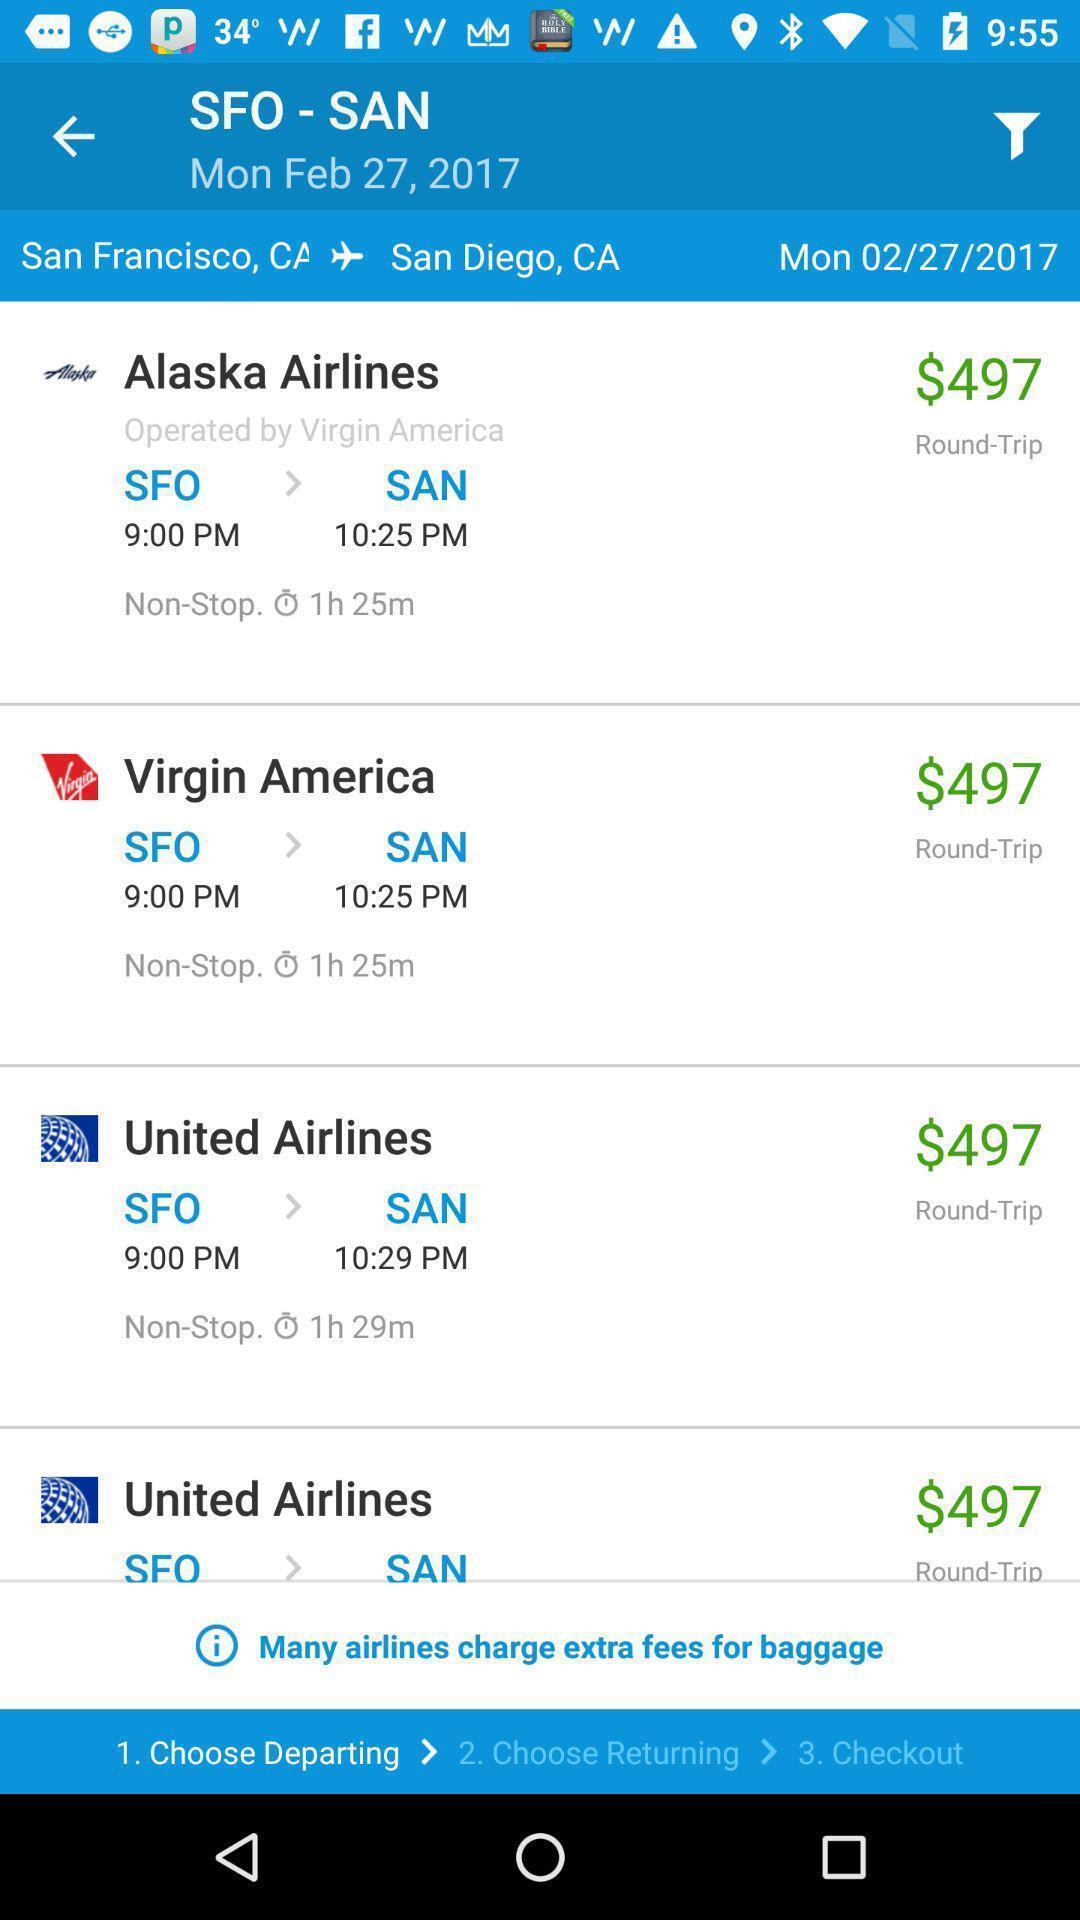What can you discern from this picture? Screen shows options for a flight app with prices. 